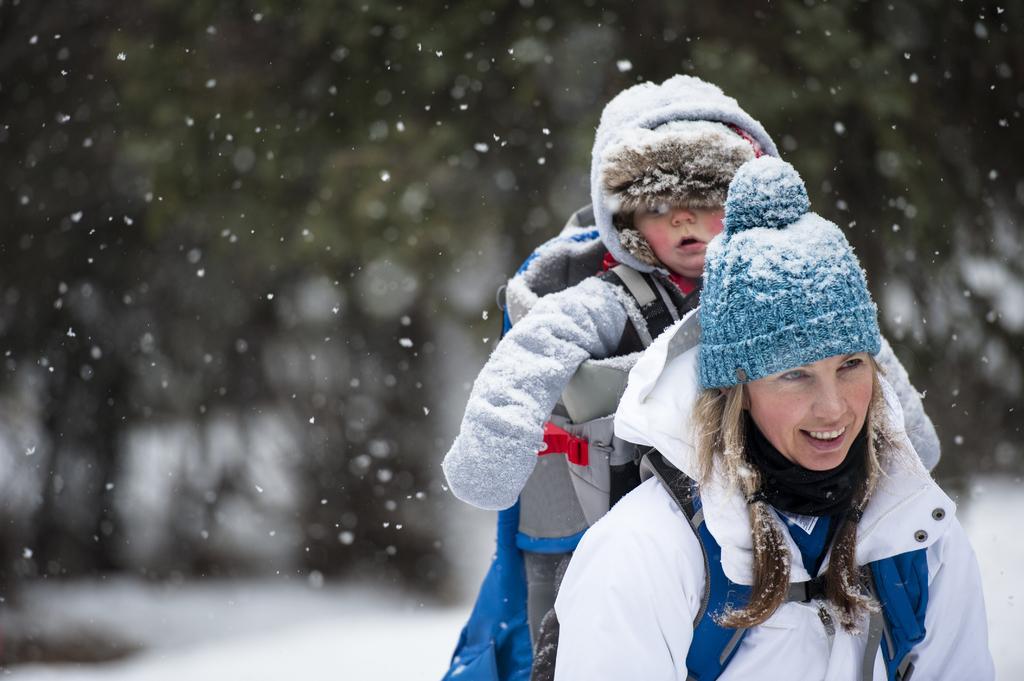How would you summarize this image in a sentence or two? In this image we can see a woman. She is wearing a white color jacket and a blue cap. She is carrying a baby in a baby carrier. Baby is wearing a jacket. The background is blurry. 